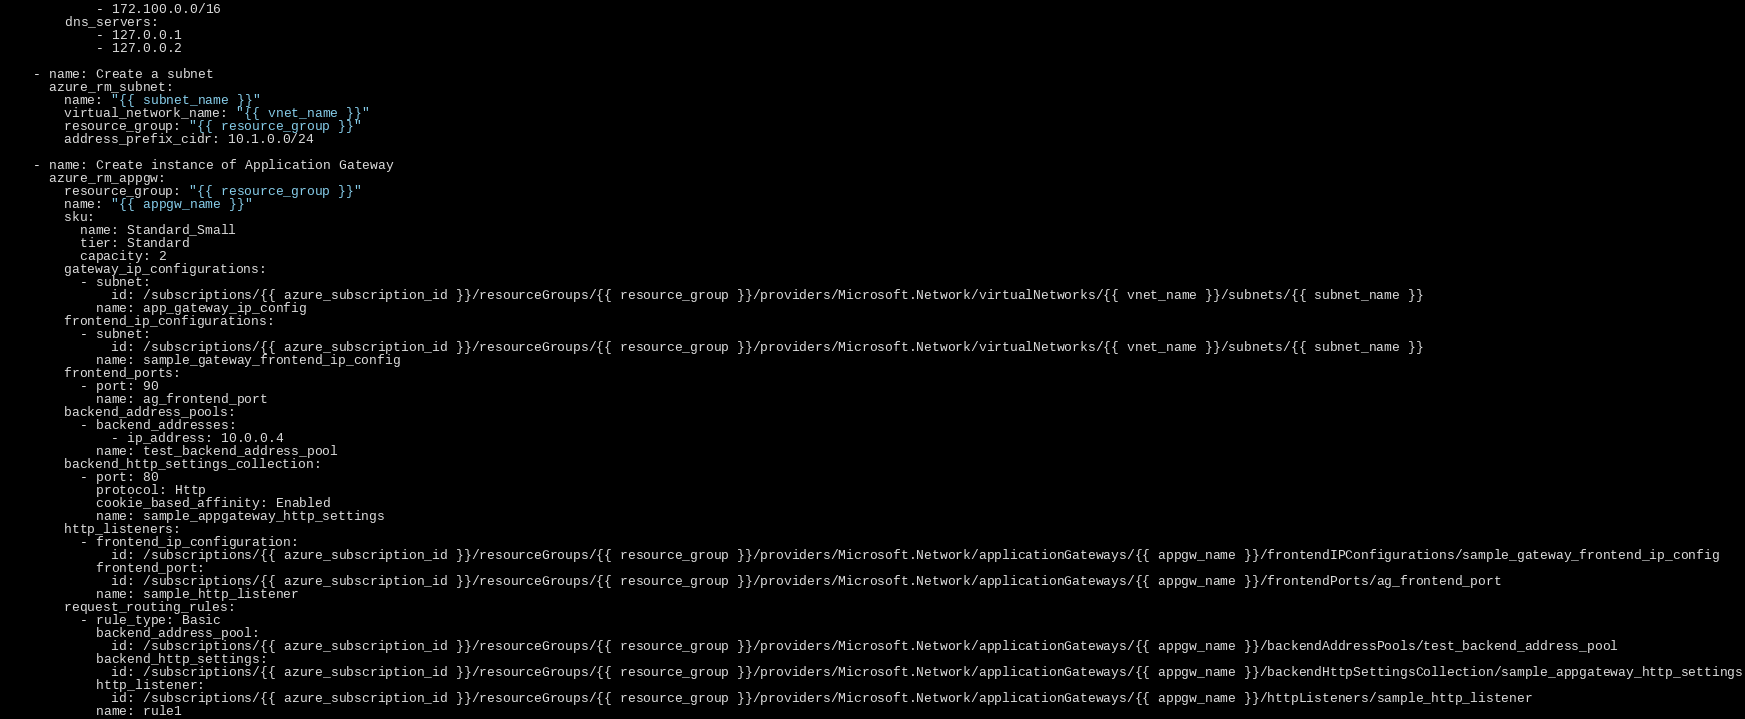<code> <loc_0><loc_0><loc_500><loc_500><_YAML_>            - 172.100.0.0/16
        dns_servers:
            - 127.0.0.1
            - 127.0.0.2

    - name: Create a subnet
      azure_rm_subnet:
        name: "{{ subnet_name }}"
        virtual_network_name: "{{ vnet_name }}"
        resource_group: "{{ resource_group }}"
        address_prefix_cidr: 10.1.0.0/24

    - name: Create instance of Application Gateway
      azure_rm_appgw:
        resource_group: "{{ resource_group }}"
        name: "{{ appgw_name }}"
        sku:
          name: Standard_Small
          tier: Standard
          capacity: 2
        gateway_ip_configurations:
          - subnet:
              id: /subscriptions/{{ azure_subscription_id }}/resourceGroups/{{ resource_group }}/providers/Microsoft.Network/virtualNetworks/{{ vnet_name }}/subnets/{{ subnet_name }}
            name: app_gateway_ip_config
        frontend_ip_configurations:
          - subnet:
              id: /subscriptions/{{ azure_subscription_id }}/resourceGroups/{{ resource_group }}/providers/Microsoft.Network/virtualNetworks/{{ vnet_name }}/subnets/{{ subnet_name }}
            name: sample_gateway_frontend_ip_config
        frontend_ports:
          - port: 90
            name: ag_frontend_port
        backend_address_pools:
          - backend_addresses:
              - ip_address: 10.0.0.4
            name: test_backend_address_pool
        backend_http_settings_collection:
          - port: 80
            protocol: Http
            cookie_based_affinity: Enabled
            name: sample_appgateway_http_settings
        http_listeners:
          - frontend_ip_configuration:
              id: /subscriptions/{{ azure_subscription_id }}/resourceGroups/{{ resource_group }}/providers/Microsoft.Network/applicationGateways/{{ appgw_name }}/frontendIPConfigurations/sample_gateway_frontend_ip_config
            frontend_port:
              id: /subscriptions/{{ azure_subscription_id }}/resourceGroups/{{ resource_group }}/providers/Microsoft.Network/applicationGateways/{{ appgw_name }}/frontendPorts/ag_frontend_port
            name: sample_http_listener
        request_routing_rules:
          - rule_type: Basic
            backend_address_pool:
              id: /subscriptions/{{ azure_subscription_id }}/resourceGroups/{{ resource_group }}/providers/Microsoft.Network/applicationGateways/{{ appgw_name }}/backendAddressPools/test_backend_address_pool
            backend_http_settings:
              id: /subscriptions/{{ azure_subscription_id }}/resourceGroups/{{ resource_group }}/providers/Microsoft.Network/applicationGateways/{{ appgw_name }}/backendHttpSettingsCollection/sample_appgateway_http_settings
            http_listener:
              id: /subscriptions/{{ azure_subscription_id }}/resourceGroups/{{ resource_group }}/providers/Microsoft.Network/applicationGateways/{{ appgw_name }}/httpListeners/sample_http_listener
            name: rule1
</code> 